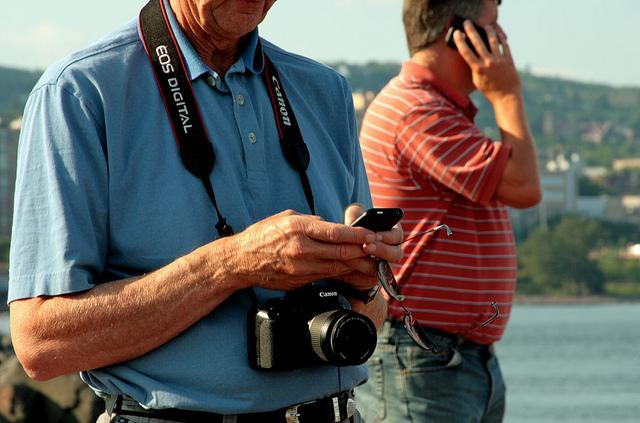What does the man do with the object around his neck?

Choices:
A) call
B) text
C) paint
D) take photos take photos 